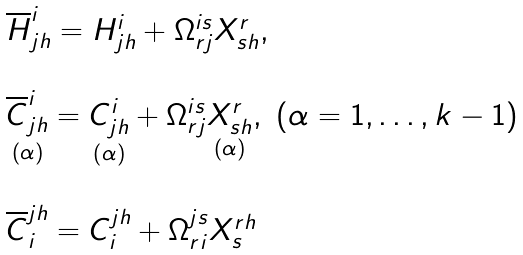Convert formula to latex. <formula><loc_0><loc_0><loc_500><loc_500>\begin{array} { l } \overline { H } _ { j h } ^ { i } = H _ { j h } ^ { i } + \Omega _ { r j } ^ { i s } X _ { s h } ^ { r } , \\ \\ \underset { \left ( \alpha \right ) } { \overline { C } _ { j h } ^ { i } } = \underset { \left ( \alpha \right ) } { C _ { j h } ^ { i } } + \Omega _ { r j } ^ { i s } \underset { \left ( \alpha \right ) } { X _ { s h } ^ { r } } , \ ( \alpha = 1 , \dots , k - 1 ) \\ \\ \overline { C } _ { i } ^ { j h } = C _ { i } ^ { j h } + \Omega _ { r i } ^ { j s } X _ { s } ^ { r h } \end{array}</formula> 